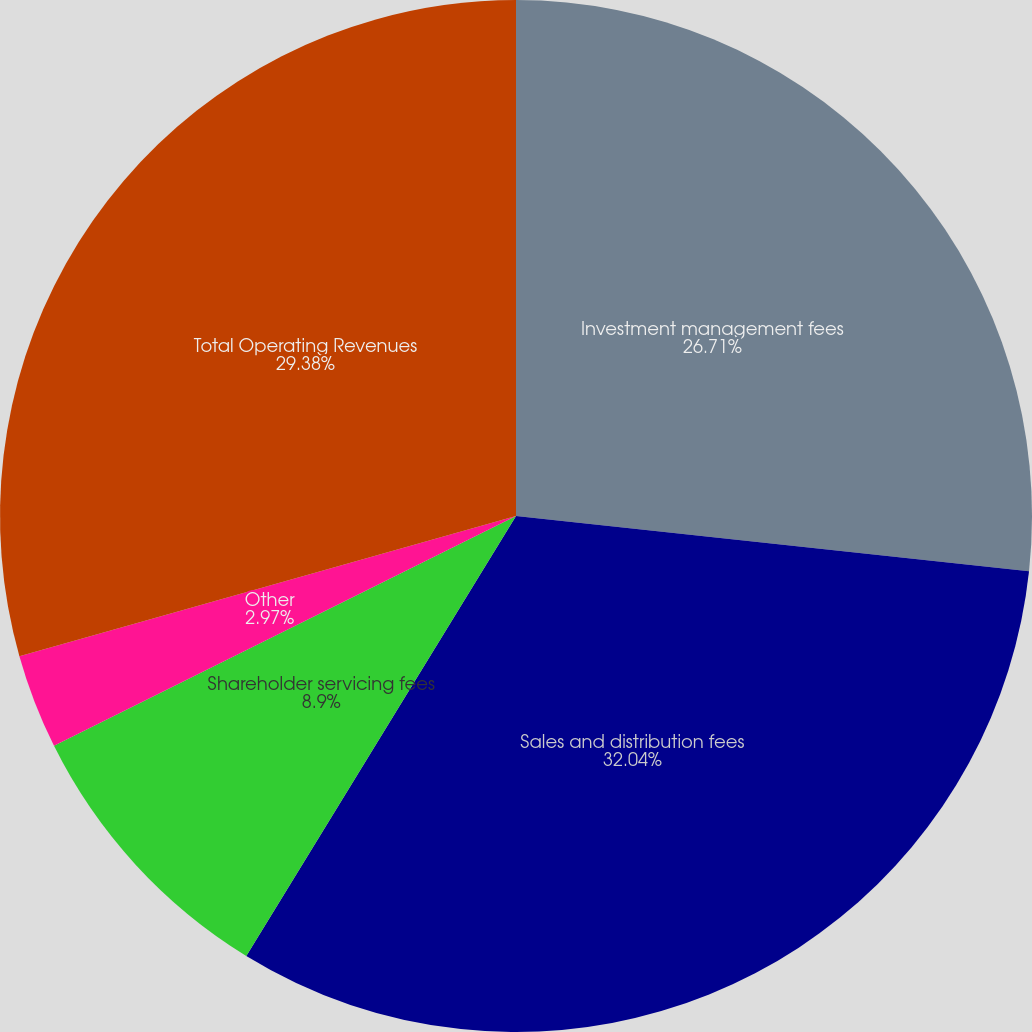<chart> <loc_0><loc_0><loc_500><loc_500><pie_chart><fcel>Investment management fees<fcel>Sales and distribution fees<fcel>Shareholder servicing fees<fcel>Other<fcel>Total Operating Revenues<nl><fcel>26.71%<fcel>32.05%<fcel>8.9%<fcel>2.97%<fcel>29.38%<nl></chart> 